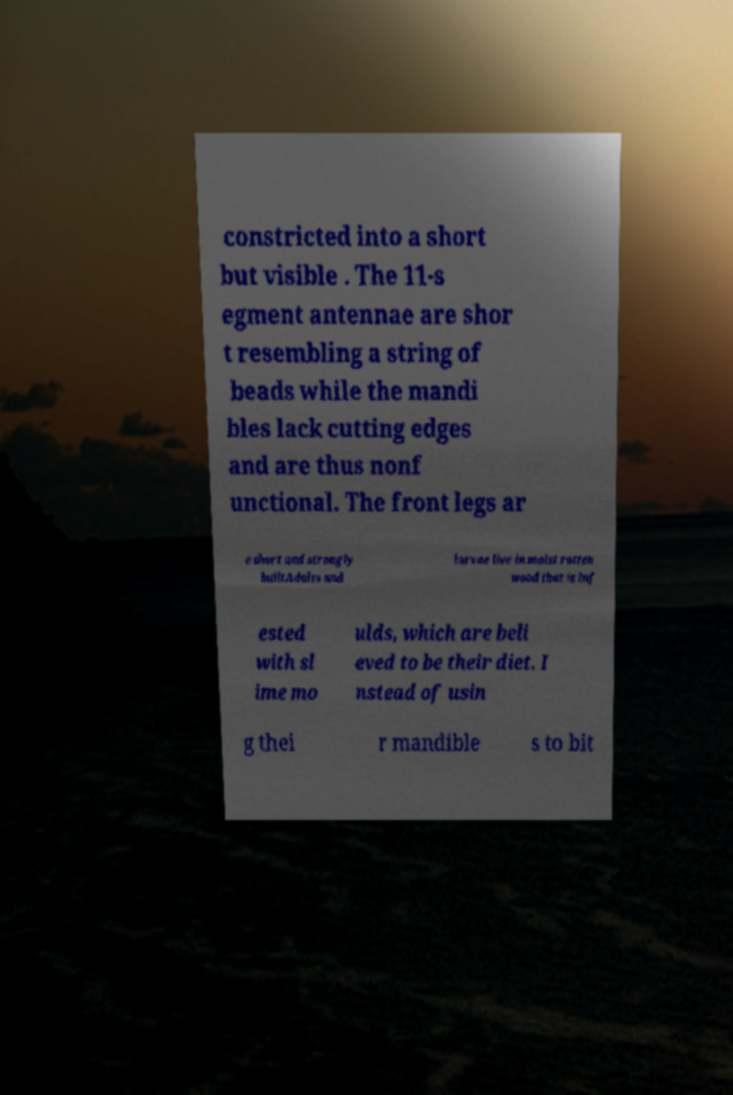Can you accurately transcribe the text from the provided image for me? constricted into a short but visible . The 11-s egment antennae are shor t resembling a string of beads while the mandi bles lack cutting edges and are thus nonf unctional. The front legs ar e short and strongly builtAdults and larvae live in moist rotten wood that is inf ested with sl ime mo ulds, which are beli eved to be their diet. I nstead of usin g thei r mandible s to bit 